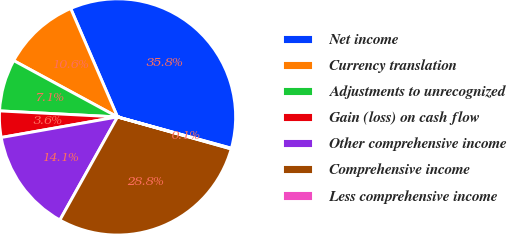<chart> <loc_0><loc_0><loc_500><loc_500><pie_chart><fcel>Net income<fcel>Currency translation<fcel>Adjustments to unrecognized<fcel>Gain (loss) on cash flow<fcel>Other comprehensive income<fcel>Comprehensive income<fcel>Less comprehensive income<nl><fcel>35.76%<fcel>10.6%<fcel>7.1%<fcel>3.6%<fcel>14.1%<fcel>28.75%<fcel>0.09%<nl></chart> 